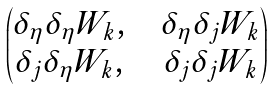Convert formula to latex. <formula><loc_0><loc_0><loc_500><loc_500>\begin{pmatrix} \delta _ { \eta } \delta _ { \eta } W _ { k } , & & \delta _ { \eta } \delta _ { j } W _ { k } \\ \delta _ { j } \delta _ { \eta } W _ { k } , & & \delta _ { j } \delta _ { j } W _ { k } \end{pmatrix}</formula> 